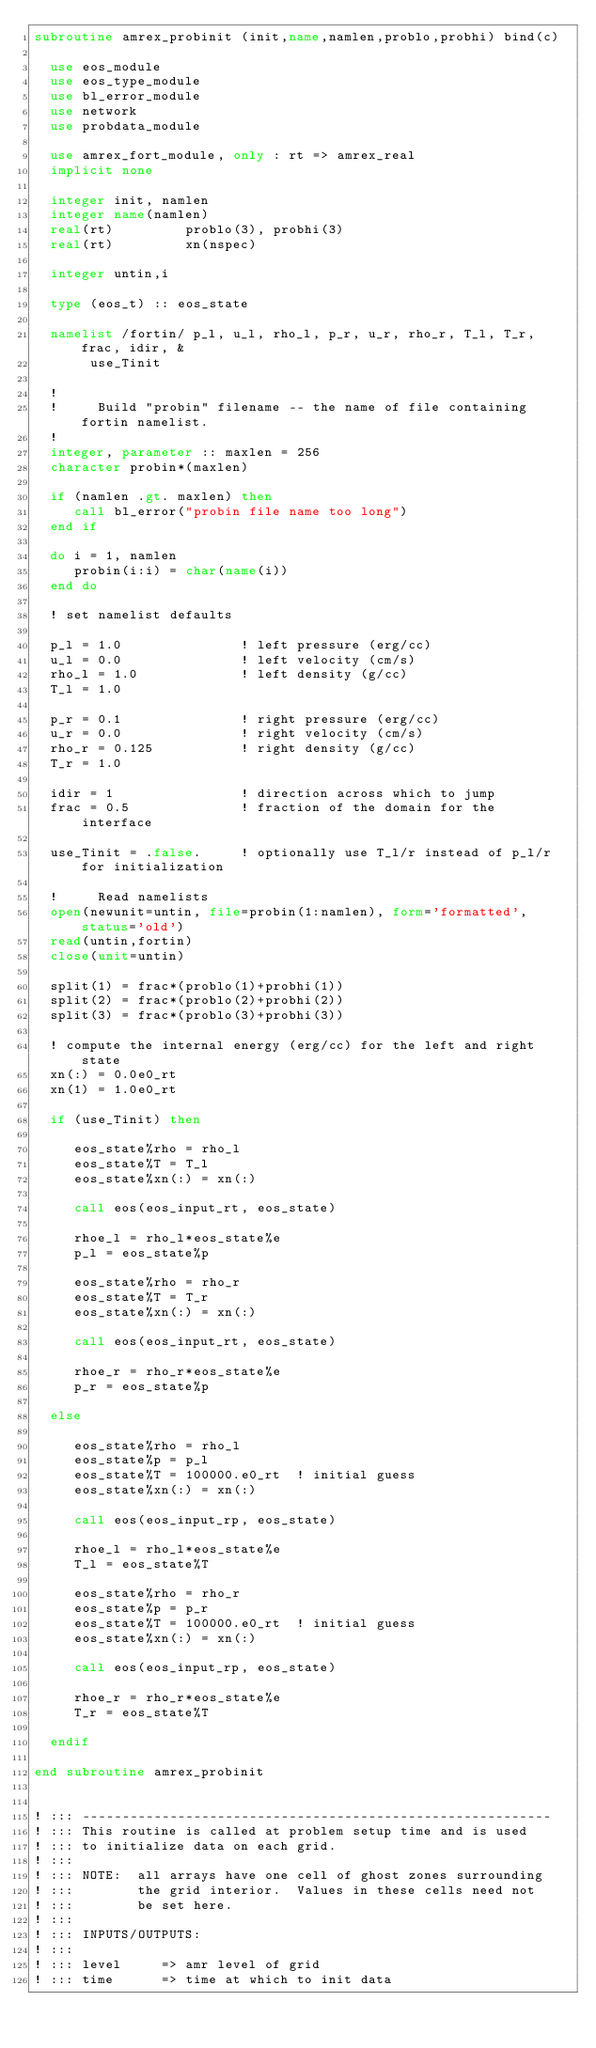<code> <loc_0><loc_0><loc_500><loc_500><_FORTRAN_>subroutine amrex_probinit (init,name,namlen,problo,probhi) bind(c)

  use eos_module
  use eos_type_module
  use bl_error_module 
  use network
  use probdata_module

  use amrex_fort_module, only : rt => amrex_real
  implicit none

  integer init, namlen
  integer name(namlen)
  real(rt)         problo(3), probhi(3)
  real(rt)         xn(nspec)

  integer untin,i

  type (eos_t) :: eos_state

  namelist /fortin/ p_l, u_l, rho_l, p_r, u_r, rho_r, T_l, T_r, frac, idir, &
       use_Tinit

  !
  !     Build "probin" filename -- the name of file containing fortin namelist.
  !     
  integer, parameter :: maxlen = 256
  character probin*(maxlen)

  if (namlen .gt. maxlen) then
     call bl_error("probin file name too long")
  end if

  do i = 1, namlen
     probin(i:i) = char(name(i))
  end do

  ! set namelist defaults

  p_l = 1.0               ! left pressure (erg/cc)
  u_l = 0.0               ! left velocity (cm/s)
  rho_l = 1.0             ! left density (g/cc)
  T_l = 1.0

  p_r = 0.1               ! right pressure (erg/cc)
  u_r = 0.0               ! right velocity (cm/s)
  rho_r = 0.125           ! right density (g/cc)
  T_r = 1.0

  idir = 1                ! direction across which to jump
  frac = 0.5              ! fraction of the domain for the interface

  use_Tinit = .false.     ! optionally use T_l/r instead of p_l/r for initialization

  !     Read namelists
  open(newunit=untin, file=probin(1:namlen), form='formatted', status='old')
  read(untin,fortin)
  close(unit=untin)

  split(1) = frac*(problo(1)+probhi(1))
  split(2) = frac*(problo(2)+probhi(2))
  split(3) = frac*(problo(3)+probhi(3))
  
  ! compute the internal energy (erg/cc) for the left and right state
  xn(:) = 0.0e0_rt
  xn(1) = 1.0e0_rt

  if (use_Tinit) then

     eos_state%rho = rho_l
     eos_state%T = T_l
     eos_state%xn(:) = xn(:)

     call eos(eos_input_rt, eos_state)
 
     rhoe_l = rho_l*eos_state%e
     p_l = eos_state%p

     eos_state%rho = rho_r
     eos_state%T = T_r
     eos_state%xn(:) = xn(:)

     call eos(eos_input_rt, eos_state)
 
     rhoe_r = rho_r*eos_state%e
     p_r = eos_state%p

  else

     eos_state%rho = rho_l
     eos_state%p = p_l
     eos_state%T = 100000.e0_rt  ! initial guess
     eos_state%xn(:) = xn(:)

     call eos(eos_input_rp, eos_state)
 
     rhoe_l = rho_l*eos_state%e
     T_l = eos_state%T

     eos_state%rho = rho_r
     eos_state%p = p_r
     eos_state%T = 100000.e0_rt  ! initial guess
     eos_state%xn(:) = xn(:)

     call eos(eos_input_rp, eos_state)
 
     rhoe_r = rho_r*eos_state%e
     T_r = eos_state%T

  endif

end subroutine amrex_probinit


! ::: -----------------------------------------------------------
! ::: This routine is called at problem setup time and is used
! ::: to initialize data on each grid.  
! ::: 
! ::: NOTE:  all arrays have one cell of ghost zones surrounding
! :::        the grid interior.  Values in these cells need not
! :::        be set here.
! ::: 
! ::: INPUTS/OUTPUTS:
! ::: 
! ::: level     => amr level of grid
! ::: time      => time at which to init data             </code> 